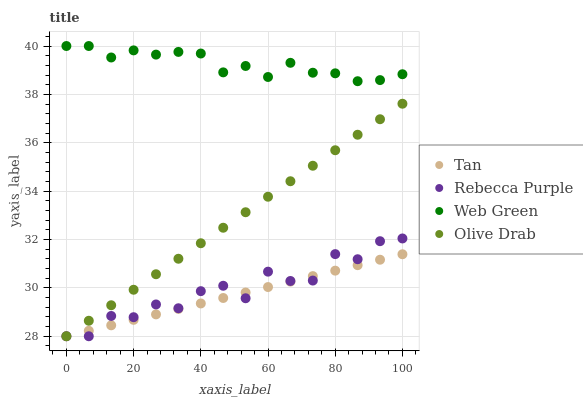Does Tan have the minimum area under the curve?
Answer yes or no. Yes. Does Web Green have the maximum area under the curve?
Answer yes or no. Yes. Does Rebecca Purple have the minimum area under the curve?
Answer yes or no. No. Does Rebecca Purple have the maximum area under the curve?
Answer yes or no. No. Is Tan the smoothest?
Answer yes or no. Yes. Is Rebecca Purple the roughest?
Answer yes or no. Yes. Is Rebecca Purple the smoothest?
Answer yes or no. No. Is Tan the roughest?
Answer yes or no. No. Does Olive Drab have the lowest value?
Answer yes or no. Yes. Does Web Green have the lowest value?
Answer yes or no. No. Does Web Green have the highest value?
Answer yes or no. Yes. Does Rebecca Purple have the highest value?
Answer yes or no. No. Is Tan less than Web Green?
Answer yes or no. Yes. Is Web Green greater than Tan?
Answer yes or no. Yes. Does Rebecca Purple intersect Tan?
Answer yes or no. Yes. Is Rebecca Purple less than Tan?
Answer yes or no. No. Is Rebecca Purple greater than Tan?
Answer yes or no. No. Does Tan intersect Web Green?
Answer yes or no. No. 